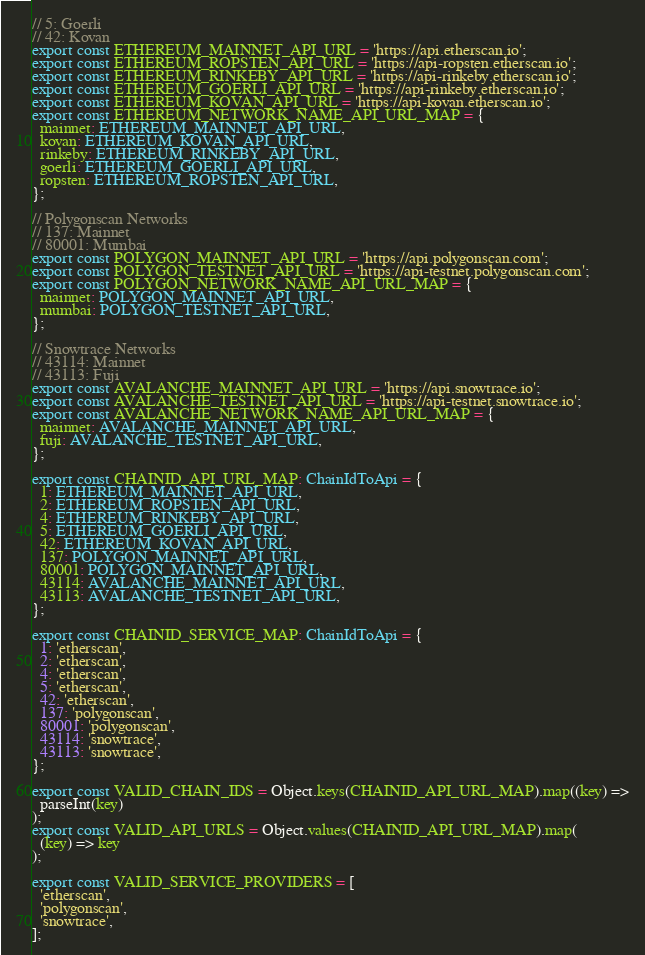<code> <loc_0><loc_0><loc_500><loc_500><_TypeScript_>// 5: Goerli
// 42: Kovan
export const ETHEREUM_MAINNET_API_URL = 'https://api.etherscan.io';
export const ETHEREUM_ROPSTEN_API_URL = 'https://api-ropsten.etherscan.io';
export const ETHEREUM_RINKEBY_API_URL = 'https://api-rinkeby.etherscan.io';
export const ETHEREUM_GOERLI_API_URL = 'https://api-rinkeby.etherscan.io';
export const ETHEREUM_KOVAN_API_URL = 'https://api-kovan.etherscan.io';
export const ETHEREUM_NETWORK_NAME_API_URL_MAP = {
  mainnet: ETHEREUM_MAINNET_API_URL,
  kovan: ETHEREUM_KOVAN_API_URL,
  rinkeby: ETHEREUM_RINKEBY_API_URL,
  goerli: ETHEREUM_GOERLI_API_URL,
  ropsten: ETHEREUM_ROPSTEN_API_URL,
};

// Polygonscan Networks
// 137: Mainnet
// 80001: Mumbai
export const POLYGON_MAINNET_API_URL = 'https://api.polygonscan.com';
export const POLYGON_TESTNET_API_URL = 'https://api-testnet.polygonscan.com';
export const POLYGON_NETWORK_NAME_API_URL_MAP = {
  mainnet: POLYGON_MAINNET_API_URL,
  mumbai: POLYGON_TESTNET_API_URL,
};

// Snowtrace Networks
// 43114: Mainnet
// 43113: Fuji
export const AVALANCHE_MAINNET_API_URL = 'https://api.snowtrace.io';
export const AVALANCHE_TESTNET_API_URL = 'https://api-testnet.snowtrace.io';
export const AVALANCHE_NETWORK_NAME_API_URL_MAP = {
  mainnet: AVALANCHE_MAINNET_API_URL,
  fuji: AVALANCHE_TESTNET_API_URL,
};

export const CHAINID_API_URL_MAP: ChainIdToApi = {
  1: ETHEREUM_MAINNET_API_URL,
  2: ETHEREUM_ROPSTEN_API_URL,
  4: ETHEREUM_RINKEBY_API_URL,
  5: ETHEREUM_GOERLI_API_URL,
  42: ETHEREUM_KOVAN_API_URL,
  137: POLYGON_MAINNET_API_URL,
  80001: POLYGON_MAINNET_API_URL,
  43114: AVALANCHE_MAINNET_API_URL,
  43113: AVALANCHE_TESTNET_API_URL,
};

export const CHAINID_SERVICE_MAP: ChainIdToApi = {
  1: 'etherscan',
  2: 'etherscan',
  4: 'etherscan',
  5: 'etherscan',
  42: 'etherscan',
  137: 'polygonscan',
  80001: 'polygonscan',
  43114: 'snowtrace',
  43113: 'snowtrace',
};

export const VALID_CHAIN_IDS = Object.keys(CHAINID_API_URL_MAP).map((key) =>
  parseInt(key)
);
export const VALID_API_URLS = Object.values(CHAINID_API_URL_MAP).map(
  (key) => key
);

export const VALID_SERVICE_PROVIDERS = [
  'etherscan',
  'polygonscan',
  'snowtrace',
];
</code> 